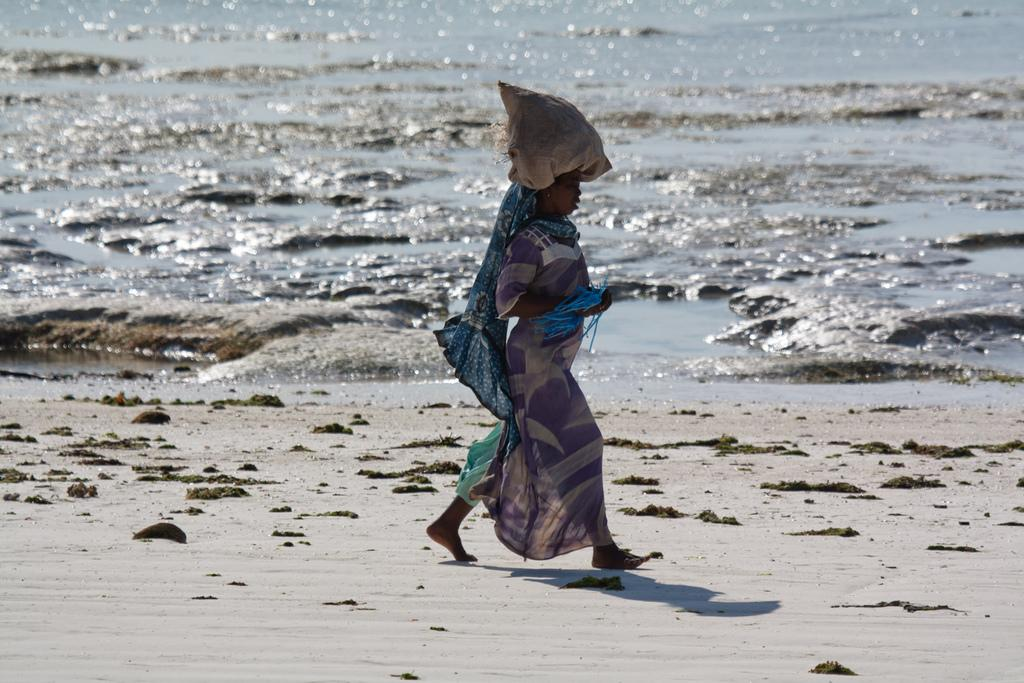What is present in the image? There is a person in the image. What colors is the person wearing? The person is wearing purple, blue, and white colors. What is unusual about the person's attire? The person has a bag on her head. What can be seen in the background of the image? There is water visible in the background of the image. How much wealth does the quartz in the image represent? There is no quartz present in the image, so it cannot be used to represent wealth. What verse is being recited by the person in the image? There is no indication in the image that the person is reciting a verse, so it cannot be determined. 